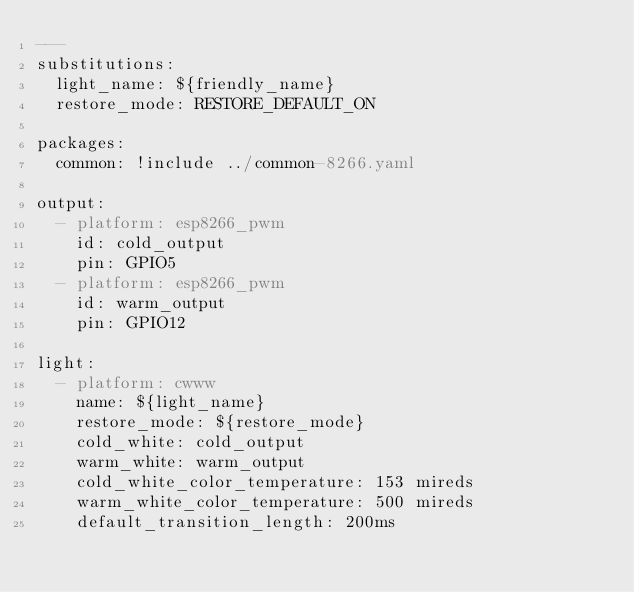Convert code to text. <code><loc_0><loc_0><loc_500><loc_500><_YAML_>---
substitutions:
  light_name: ${friendly_name}
  restore_mode: RESTORE_DEFAULT_ON

packages:
  common: !include ../common-8266.yaml

output:
  - platform: esp8266_pwm
    id: cold_output
    pin: GPIO5
  - platform: esp8266_pwm
    id: warm_output
    pin: GPIO12

light:
  - platform: cwww
    name: ${light_name}
    restore_mode: ${restore_mode}
    cold_white: cold_output
    warm_white: warm_output
    cold_white_color_temperature: 153 mireds
    warm_white_color_temperature: 500 mireds
    default_transition_length: 200ms
</code> 